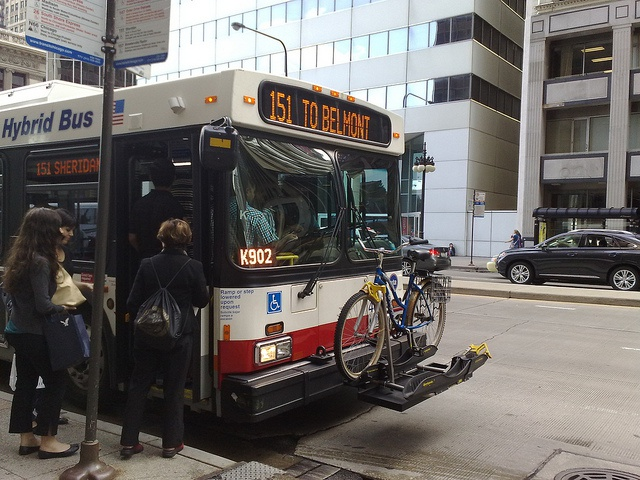Describe the objects in this image and their specific colors. I can see bus in darkgray, black, gray, and lightgray tones, people in darkgray, black, and gray tones, people in darkgray, black, gray, and maroon tones, bicycle in darkgray, black, gray, and maroon tones, and car in darkgray, black, gray, and lightgray tones in this image. 